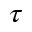<formula> <loc_0><loc_0><loc_500><loc_500>\tau</formula> 